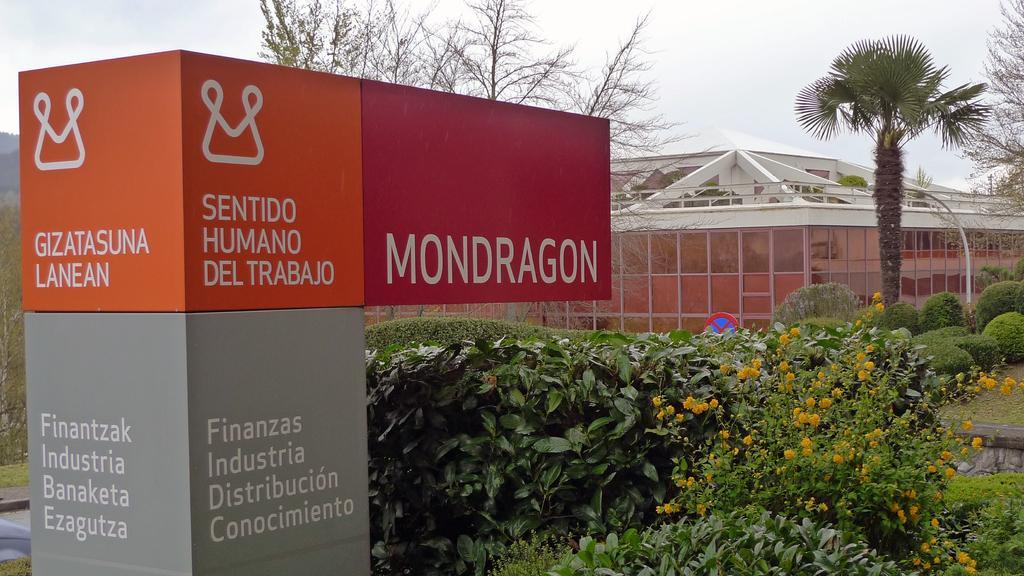Can you describe this image briefly? In this image we can see boards, plants, flowers, trees, and a building. In the background there is sky. 